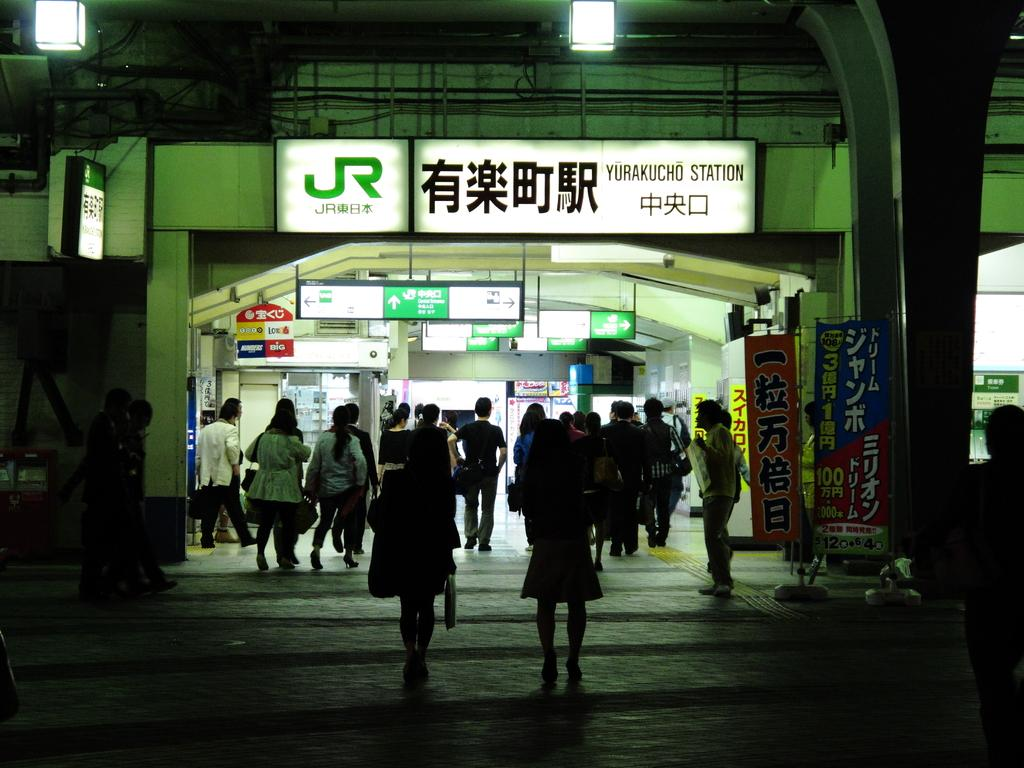Provide a one-sentence caption for the provided image. A far shot of the Yurakucho Station taken at night. 